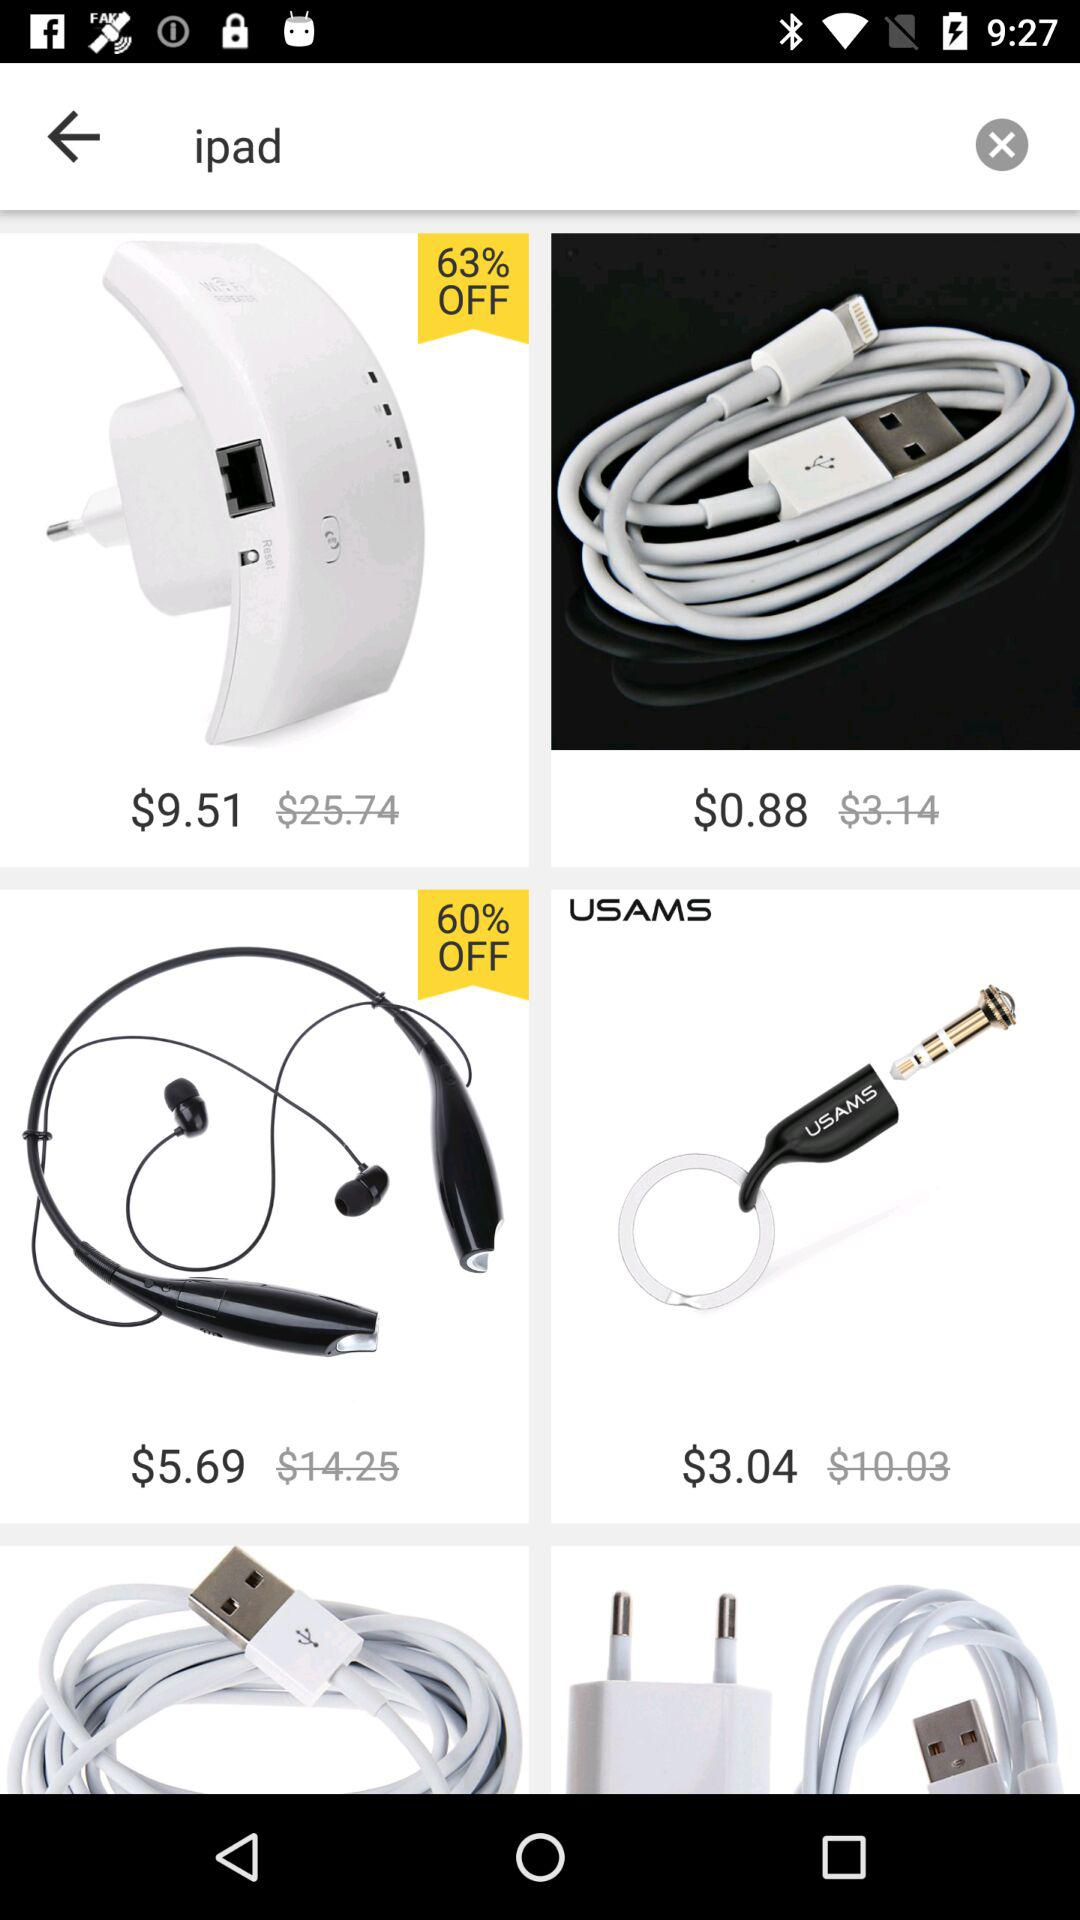What is the original price of the iPad which is 60% off?
When the provided information is insufficient, respond with <no answer>. <no answer> 